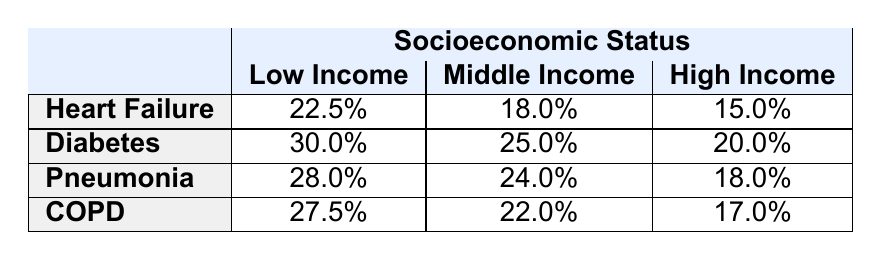What is the readmission rate for patients with Heart Failure who are classified as Low Income? From the table, we can reference the row for "Heart Failure" and look under the "Low Income" column. The readmission rate listed there is 22.5%.
Answer: 22.5% What is the readmission rate for patients with Diabetes in the High Income category? The table shows that under the "Diabetes" row and the "High Income" column, the readmission rate is 20.0%.
Answer: 20.0% Is the readmission rate for Low Income patients with Pneumonia higher than that for Middle Income patients? By checking the "Pneumonia" row, the "Low Income" readmission rate is 28.0%, while the "Middle Income" rate is 24.0%. Since 28.0% is greater than 24.0%, the statement is true.
Answer: Yes What is the average readmission rate for COPD across all socioeconomic statuses? We will calculate the average by taking the readmission rates for COPD: 27.5% (Low Income), 22.0% (Middle Income), and 17.0% (High Income). Adding these gives us 27.5 + 22.0 + 17.0 = 66.5%. Then, dividing by 3 (the number of income categories) gives us an average of 66.5% / 3 = 22.17%.
Answer: 22.17% Which disease category has the highest readmission rate for Middle Income patients? By examining the Middle Income column for all disease categories, we find: Heart Failure (18.0%), Diabetes (25.0%), Pneumonia (24.0%), and COPD (22.0%). The maximum value among these is 25.0%, which corresponds to Diabetes.
Answer: Diabetes What is the difference in readmission rates between Low Income patients with Diabetes and Low Income patients with Heart Failure? Checking the "Low Income" rates in the Diabetes row (30.0%) and the Heart Failure row (22.5%), we find that 30.0% - 22.5% = 7.5%. Hence, the difference is 7.5%.
Answer: 7.5% Does the readmission rate decrease consistently from Low Income to High Income for all disease categories? By analyzing the readmission rates for each disease category: Heart Failure (22.5%, 18.0%, 15.0%), Diabetes (30.0%, 25.0%, 20.0%), Pneumonia (28.0%, 24.0%, 18.0%), and COPD (27.5%, 22.0%, 17.0%), we see that while it decreases for each, Diabetes does not decrease in comparison to Heart Failure in every case, thus we cannot say it decreases consistently.
Answer: No What is the readmission rate for High Income patients with Pneumonia? From the table, we can see that the Pneumonia row under the High Income category lists a readmission rate of 18.0%.
Answer: 18.0% 